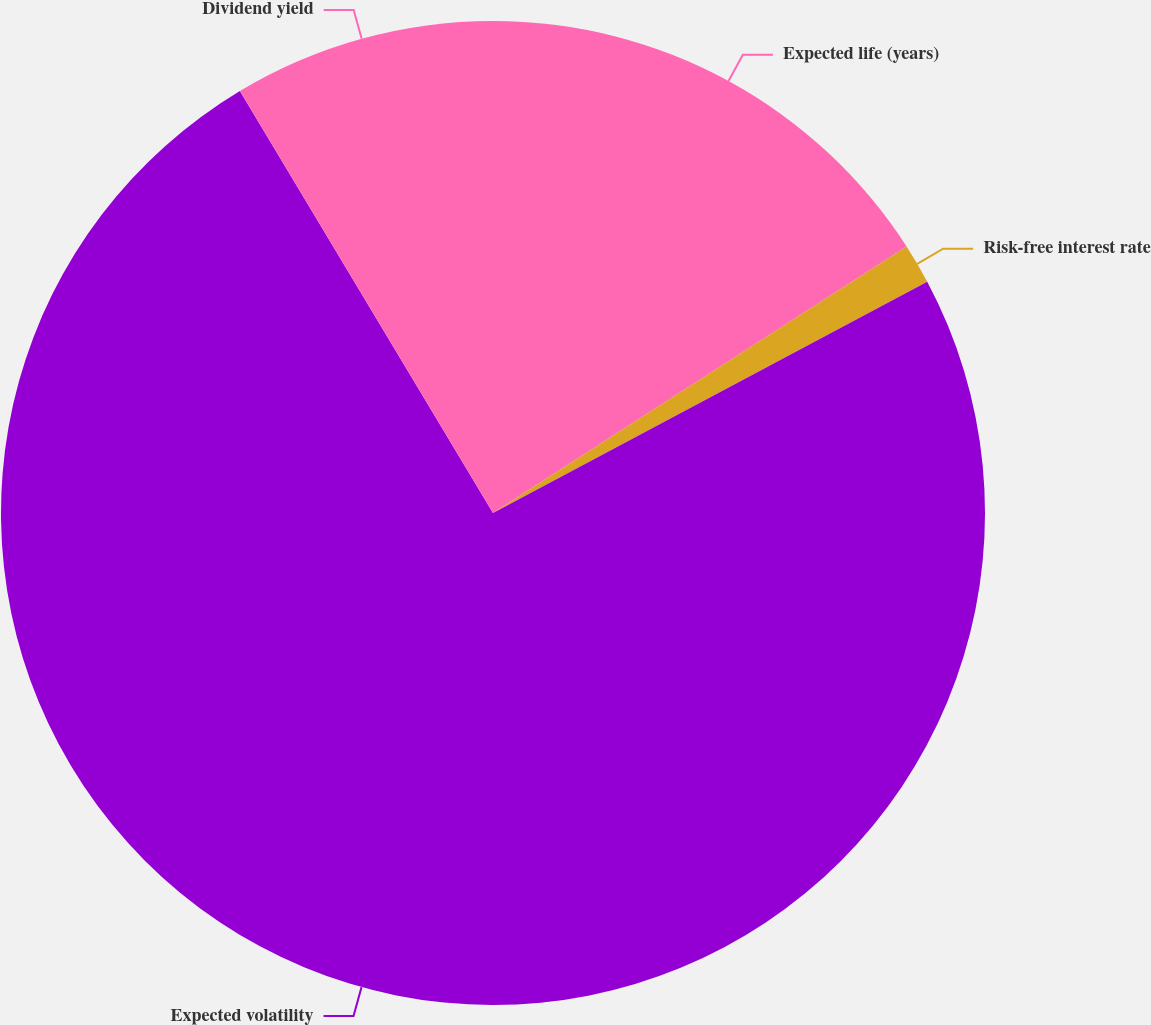<chart> <loc_0><loc_0><loc_500><loc_500><pie_chart><fcel>Expected life (years)<fcel>Risk-free interest rate<fcel>Expected volatility<fcel>Dividend yield<nl><fcel>15.89%<fcel>1.32%<fcel>74.19%<fcel>8.6%<nl></chart> 